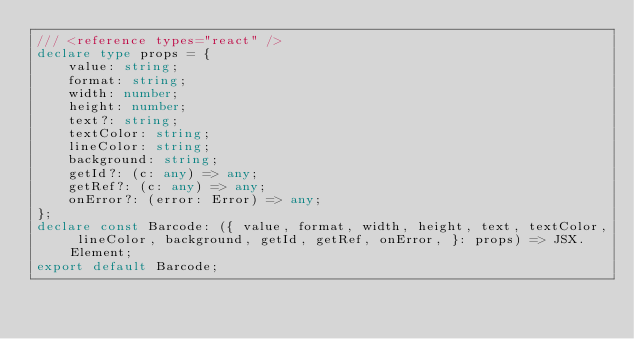Convert code to text. <code><loc_0><loc_0><loc_500><loc_500><_TypeScript_>/// <reference types="react" />
declare type props = {
    value: string;
    format: string;
    width: number;
    height: number;
    text?: string;
    textColor: string;
    lineColor: string;
    background: string;
    getId?: (c: any) => any;
    getRef?: (c: any) => any;
    onError?: (error: Error) => any;
};
declare const Barcode: ({ value, format, width, height, text, textColor, lineColor, background, getId, getRef, onError, }: props) => JSX.Element;
export default Barcode;
</code> 